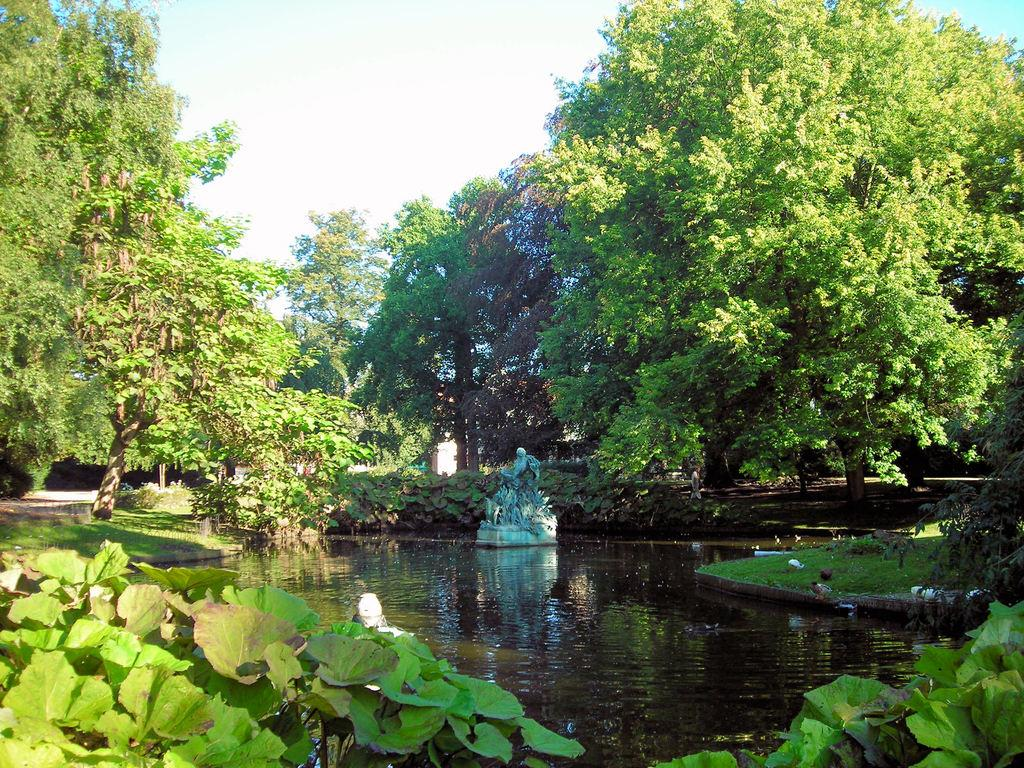What is the main feature in the center of the image? There is a fountain in the center of the image. Where is the fountain located? The fountain is in a pond. What can be seen in the background of the image? There are many trees and the sky visible in the background of the image. What is present in the foreground of the image? There is grass and plants in the foreground of the image. What type of silk is being produced in the plantation shown in the image? There is no plantation or silk production visible in the image; it features a fountain in a pond with trees, sky, grass, and plants in the background and foreground. 